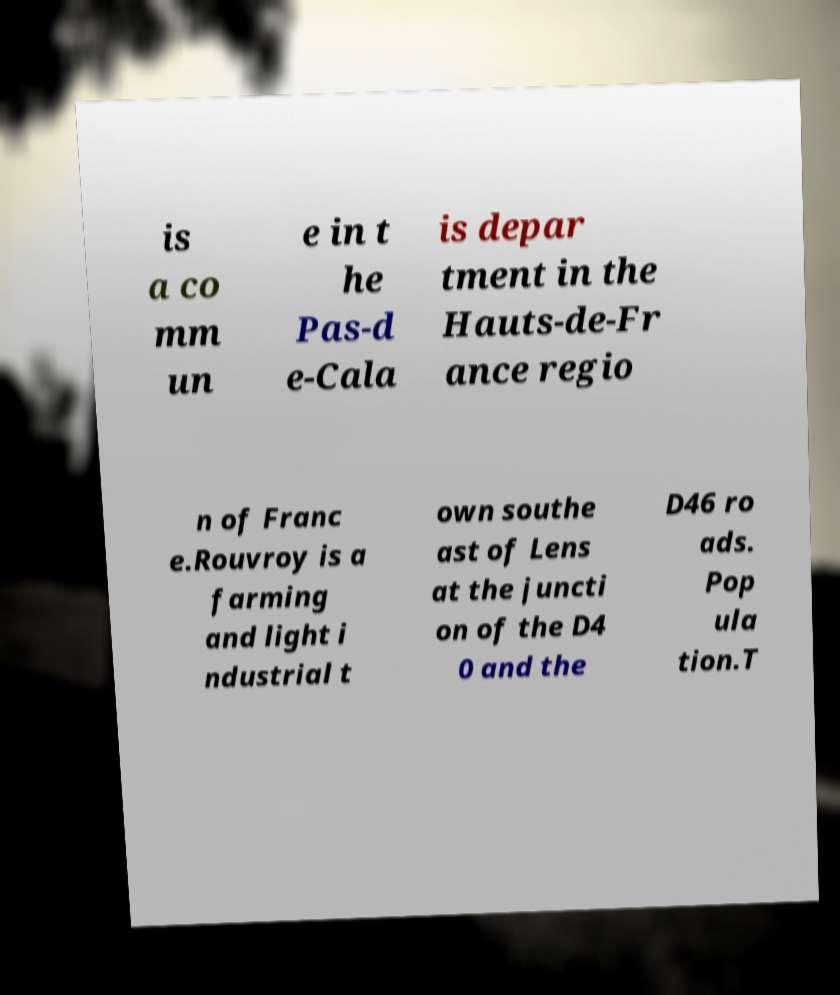Can you read and provide the text displayed in the image?This photo seems to have some interesting text. Can you extract and type it out for me? is a co mm un e in t he Pas-d e-Cala is depar tment in the Hauts-de-Fr ance regio n of Franc e.Rouvroy is a farming and light i ndustrial t own southe ast of Lens at the juncti on of the D4 0 and the D46 ro ads. Pop ula tion.T 